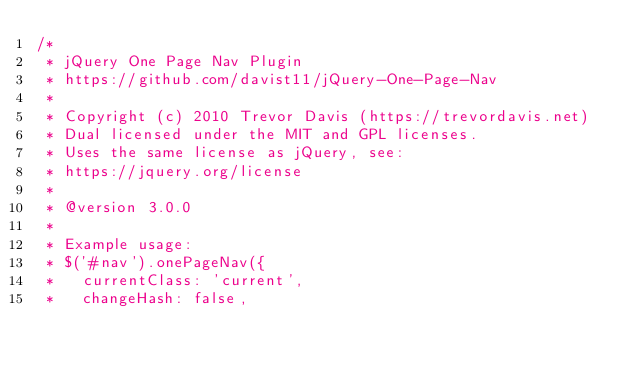<code> <loc_0><loc_0><loc_500><loc_500><_JavaScript_>/*
 * jQuery One Page Nav Plugin
 * https://github.com/davist11/jQuery-One-Page-Nav
 *
 * Copyright (c) 2010 Trevor Davis (https://trevordavis.net)
 * Dual licensed under the MIT and GPL licenses.
 * Uses the same license as jQuery, see:
 * https://jquery.org/license
 *
 * @version 3.0.0
 *
 * Example usage:
 * $('#nav').onePageNav({
 *   currentClass: 'current',
 *   changeHash: false,</code> 